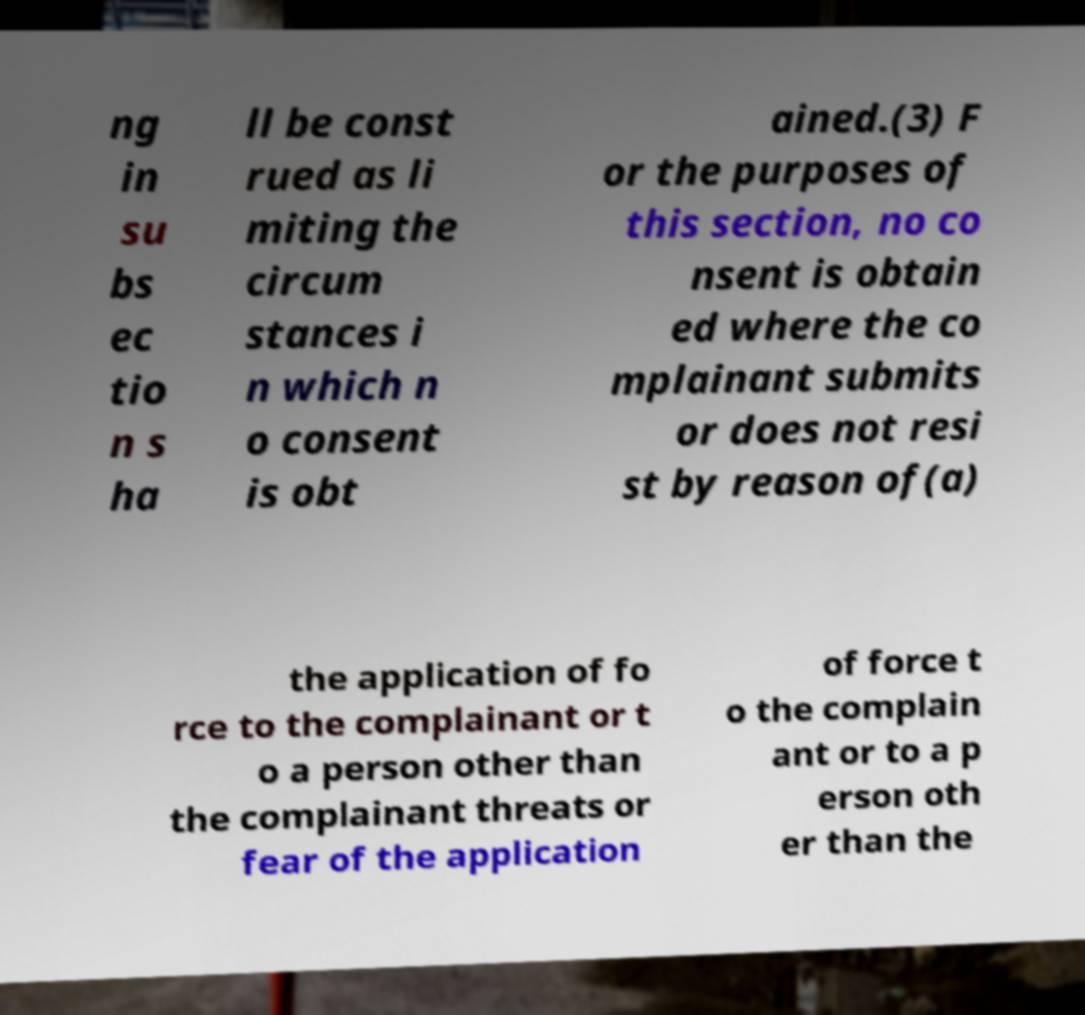Could you extract and type out the text from this image? ng in su bs ec tio n s ha ll be const rued as li miting the circum stances i n which n o consent is obt ained.(3) F or the purposes of this section, no co nsent is obtain ed where the co mplainant submits or does not resi st by reason of(a) the application of fo rce to the complainant or t o a person other than the complainant threats or fear of the application of force t o the complain ant or to a p erson oth er than the 